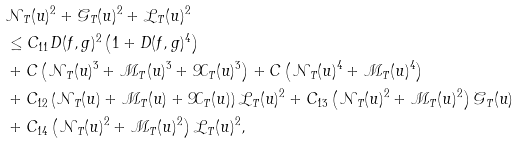<formula> <loc_0><loc_0><loc_500><loc_500>& { \mathcal { N } } _ { T } ( u ) ^ { 2 } + { \mathcal { G } } _ { T } ( u ) ^ { 2 } + { \mathcal { L } } _ { T } ( u ) ^ { 2 } \\ & \leq C _ { 1 1 } D ( f , g ) ^ { 2 } \left ( 1 + D ( f , g ) ^ { 4 } \right ) \\ & + C \left ( { \mathcal { N } } _ { T } ( u ) ^ { 3 } + { \mathcal { M } } _ { T } ( u ) ^ { 3 } + { \mathcal { X } } _ { T } ( u ) ^ { 3 } \right ) + C \left ( { \mathcal { N } } _ { T } ( u ) ^ { 4 } + { \mathcal { M } } _ { T } ( u ) ^ { 4 } \right ) \\ & + C _ { 1 2 } \left ( { \mathcal { N } } _ { T } ( u ) + { \mathcal { M } } _ { T } ( u ) + { \mathcal { X } } _ { T } ( u ) \right ) { \mathcal { L } } _ { T } ( u ) ^ { 2 } + C _ { 1 3 } \left ( { \mathcal { N } } _ { T } ( u ) ^ { 2 } + { \mathcal { M } } _ { T } ( u ) ^ { 2 } \right ) { \mathcal { G } } _ { T } ( u ) \\ & + C _ { 1 4 } \left ( { \mathcal { N } } _ { T } ( u ) ^ { 2 } + { \mathcal { M } } _ { T } ( u ) ^ { 2 } \right ) { \mathcal { L } } _ { T } ( u ) ^ { 2 } ,</formula> 